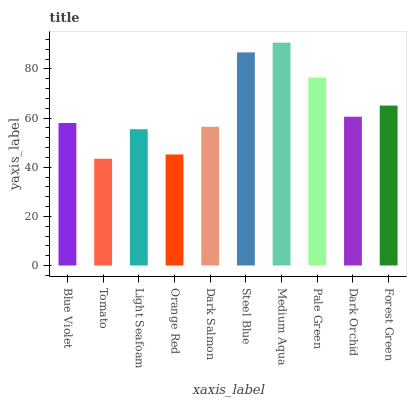Is Light Seafoam the minimum?
Answer yes or no. No. Is Light Seafoam the maximum?
Answer yes or no. No. Is Light Seafoam greater than Tomato?
Answer yes or no. Yes. Is Tomato less than Light Seafoam?
Answer yes or no. Yes. Is Tomato greater than Light Seafoam?
Answer yes or no. No. Is Light Seafoam less than Tomato?
Answer yes or no. No. Is Dark Orchid the high median?
Answer yes or no. Yes. Is Blue Violet the low median?
Answer yes or no. Yes. Is Dark Salmon the high median?
Answer yes or no. No. Is Medium Aqua the low median?
Answer yes or no. No. 